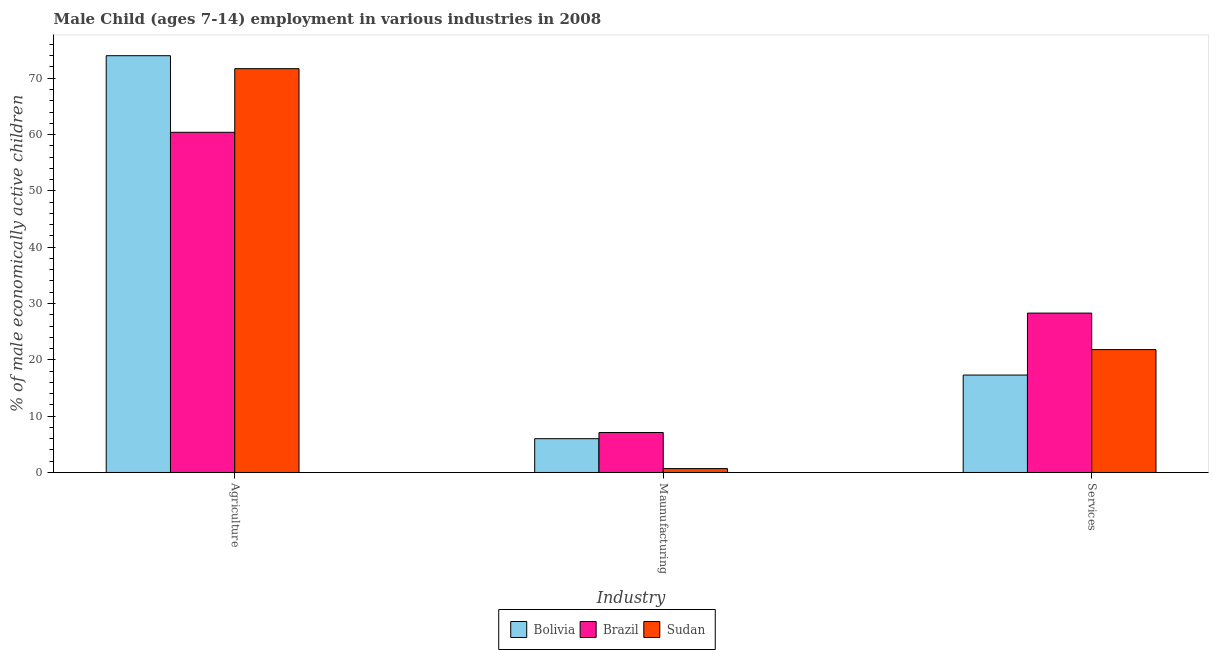How many different coloured bars are there?
Provide a succinct answer. 3. Are the number of bars per tick equal to the number of legend labels?
Your answer should be very brief. Yes. Are the number of bars on each tick of the X-axis equal?
Offer a terse response. Yes. What is the label of the 2nd group of bars from the left?
Provide a short and direct response. Maunufacturing. What is the percentage of economically active children in services in Brazil?
Make the answer very short. 28.3. Across all countries, what is the minimum percentage of economically active children in agriculture?
Provide a succinct answer. 60.4. In which country was the percentage of economically active children in services minimum?
Give a very brief answer. Bolivia. What is the total percentage of economically active children in manufacturing in the graph?
Give a very brief answer. 13.79. What is the difference between the percentage of economically active children in manufacturing in Bolivia and that in Brazil?
Offer a terse response. -1.1. What is the difference between the percentage of economically active children in manufacturing in Brazil and the percentage of economically active children in services in Bolivia?
Offer a very short reply. -10.2. What is the average percentage of economically active children in manufacturing per country?
Keep it short and to the point. 4.6. What is the difference between the percentage of economically active children in manufacturing and percentage of economically active children in agriculture in Bolivia?
Ensure brevity in your answer.  -68. What is the ratio of the percentage of economically active children in manufacturing in Brazil to that in Sudan?
Ensure brevity in your answer.  10.29. What is the difference between the highest and the second highest percentage of economically active children in services?
Provide a short and direct response. 6.48. What is the difference between the highest and the lowest percentage of economically active children in manufacturing?
Keep it short and to the point. 6.41. In how many countries, is the percentage of economically active children in agriculture greater than the average percentage of economically active children in agriculture taken over all countries?
Provide a succinct answer. 2. Is the sum of the percentage of economically active children in agriculture in Sudan and Bolivia greater than the maximum percentage of economically active children in services across all countries?
Your response must be concise. Yes. What does the 1st bar from the left in Services represents?
Offer a very short reply. Bolivia. What does the 2nd bar from the right in Services represents?
Your answer should be compact. Brazil. How many bars are there?
Offer a terse response. 9. What is the difference between two consecutive major ticks on the Y-axis?
Your answer should be compact. 10. Does the graph contain grids?
Provide a succinct answer. No. What is the title of the graph?
Your answer should be very brief. Male Child (ages 7-14) employment in various industries in 2008. What is the label or title of the X-axis?
Your answer should be compact. Industry. What is the label or title of the Y-axis?
Keep it short and to the point. % of male economically active children. What is the % of male economically active children of Bolivia in Agriculture?
Your answer should be very brief. 74. What is the % of male economically active children of Brazil in Agriculture?
Provide a short and direct response. 60.4. What is the % of male economically active children of Sudan in Agriculture?
Your answer should be very brief. 71.7. What is the % of male economically active children of Bolivia in Maunufacturing?
Your answer should be very brief. 6. What is the % of male economically active children in Sudan in Maunufacturing?
Provide a succinct answer. 0.69. What is the % of male economically active children in Bolivia in Services?
Give a very brief answer. 17.3. What is the % of male economically active children in Brazil in Services?
Give a very brief answer. 28.3. What is the % of male economically active children in Sudan in Services?
Your answer should be very brief. 21.82. Across all Industry, what is the maximum % of male economically active children in Brazil?
Ensure brevity in your answer.  60.4. Across all Industry, what is the maximum % of male economically active children of Sudan?
Ensure brevity in your answer.  71.7. Across all Industry, what is the minimum % of male economically active children in Brazil?
Offer a very short reply. 7.1. Across all Industry, what is the minimum % of male economically active children in Sudan?
Provide a succinct answer. 0.69. What is the total % of male economically active children in Bolivia in the graph?
Your answer should be compact. 97.3. What is the total % of male economically active children in Brazil in the graph?
Keep it short and to the point. 95.8. What is the total % of male economically active children in Sudan in the graph?
Give a very brief answer. 94.21. What is the difference between the % of male economically active children in Brazil in Agriculture and that in Maunufacturing?
Provide a short and direct response. 53.3. What is the difference between the % of male economically active children in Sudan in Agriculture and that in Maunufacturing?
Your answer should be very brief. 71.01. What is the difference between the % of male economically active children in Bolivia in Agriculture and that in Services?
Offer a very short reply. 56.7. What is the difference between the % of male economically active children of Brazil in Agriculture and that in Services?
Offer a terse response. 32.1. What is the difference between the % of male economically active children in Sudan in Agriculture and that in Services?
Give a very brief answer. 49.88. What is the difference between the % of male economically active children of Bolivia in Maunufacturing and that in Services?
Your response must be concise. -11.3. What is the difference between the % of male economically active children of Brazil in Maunufacturing and that in Services?
Make the answer very short. -21.2. What is the difference between the % of male economically active children in Sudan in Maunufacturing and that in Services?
Ensure brevity in your answer.  -21.13. What is the difference between the % of male economically active children of Bolivia in Agriculture and the % of male economically active children of Brazil in Maunufacturing?
Your response must be concise. 66.9. What is the difference between the % of male economically active children in Bolivia in Agriculture and the % of male economically active children in Sudan in Maunufacturing?
Make the answer very short. 73.31. What is the difference between the % of male economically active children in Brazil in Agriculture and the % of male economically active children in Sudan in Maunufacturing?
Make the answer very short. 59.71. What is the difference between the % of male economically active children in Bolivia in Agriculture and the % of male economically active children in Brazil in Services?
Keep it short and to the point. 45.7. What is the difference between the % of male economically active children in Bolivia in Agriculture and the % of male economically active children in Sudan in Services?
Your answer should be compact. 52.18. What is the difference between the % of male economically active children in Brazil in Agriculture and the % of male economically active children in Sudan in Services?
Offer a terse response. 38.58. What is the difference between the % of male economically active children of Bolivia in Maunufacturing and the % of male economically active children of Brazil in Services?
Provide a succinct answer. -22.3. What is the difference between the % of male economically active children of Bolivia in Maunufacturing and the % of male economically active children of Sudan in Services?
Give a very brief answer. -15.82. What is the difference between the % of male economically active children in Brazil in Maunufacturing and the % of male economically active children in Sudan in Services?
Make the answer very short. -14.72. What is the average % of male economically active children in Bolivia per Industry?
Keep it short and to the point. 32.43. What is the average % of male economically active children in Brazil per Industry?
Ensure brevity in your answer.  31.93. What is the average % of male economically active children in Sudan per Industry?
Give a very brief answer. 31.4. What is the difference between the % of male economically active children in Bolivia and % of male economically active children in Sudan in Agriculture?
Provide a short and direct response. 2.3. What is the difference between the % of male economically active children in Brazil and % of male economically active children in Sudan in Agriculture?
Your answer should be compact. -11.3. What is the difference between the % of male economically active children in Bolivia and % of male economically active children in Sudan in Maunufacturing?
Ensure brevity in your answer.  5.31. What is the difference between the % of male economically active children of Brazil and % of male economically active children of Sudan in Maunufacturing?
Keep it short and to the point. 6.41. What is the difference between the % of male economically active children of Bolivia and % of male economically active children of Brazil in Services?
Your answer should be very brief. -11. What is the difference between the % of male economically active children of Bolivia and % of male economically active children of Sudan in Services?
Your response must be concise. -4.52. What is the difference between the % of male economically active children of Brazil and % of male economically active children of Sudan in Services?
Give a very brief answer. 6.48. What is the ratio of the % of male economically active children in Bolivia in Agriculture to that in Maunufacturing?
Offer a very short reply. 12.33. What is the ratio of the % of male economically active children of Brazil in Agriculture to that in Maunufacturing?
Provide a short and direct response. 8.51. What is the ratio of the % of male economically active children in Sudan in Agriculture to that in Maunufacturing?
Your response must be concise. 103.91. What is the ratio of the % of male economically active children in Bolivia in Agriculture to that in Services?
Keep it short and to the point. 4.28. What is the ratio of the % of male economically active children of Brazil in Agriculture to that in Services?
Offer a very short reply. 2.13. What is the ratio of the % of male economically active children of Sudan in Agriculture to that in Services?
Your answer should be compact. 3.29. What is the ratio of the % of male economically active children of Bolivia in Maunufacturing to that in Services?
Offer a terse response. 0.35. What is the ratio of the % of male economically active children in Brazil in Maunufacturing to that in Services?
Provide a succinct answer. 0.25. What is the ratio of the % of male economically active children of Sudan in Maunufacturing to that in Services?
Your answer should be very brief. 0.03. What is the difference between the highest and the second highest % of male economically active children in Bolivia?
Ensure brevity in your answer.  56.7. What is the difference between the highest and the second highest % of male economically active children in Brazil?
Provide a succinct answer. 32.1. What is the difference between the highest and the second highest % of male economically active children of Sudan?
Your answer should be compact. 49.88. What is the difference between the highest and the lowest % of male economically active children of Brazil?
Your answer should be very brief. 53.3. What is the difference between the highest and the lowest % of male economically active children of Sudan?
Your response must be concise. 71.01. 